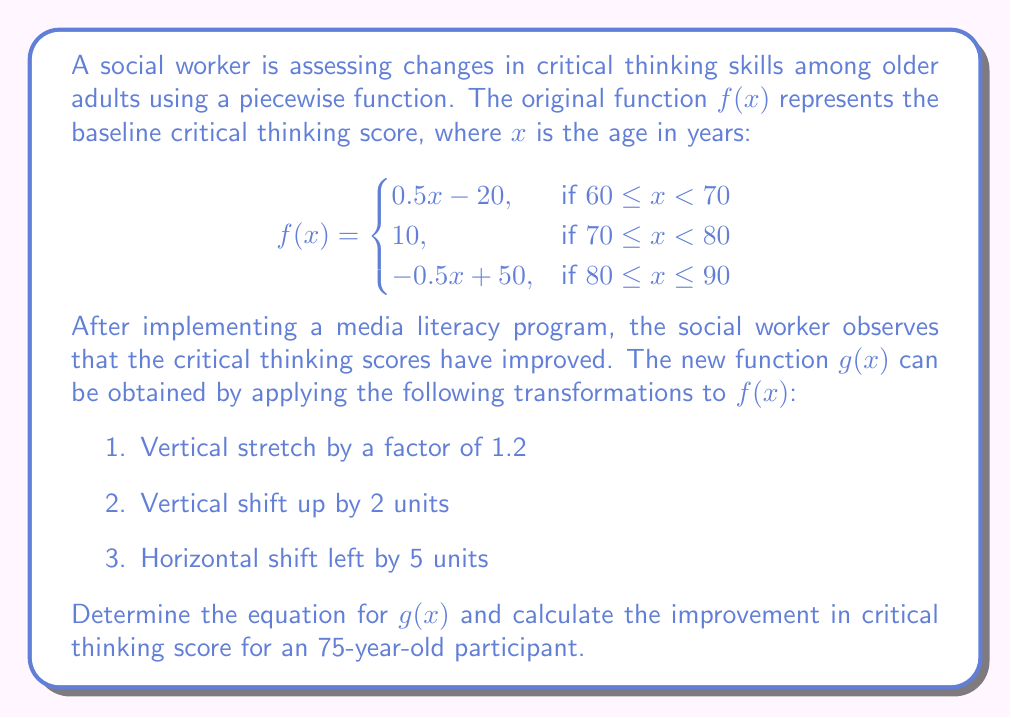Can you solve this math problem? Let's approach this step-by-step:

1) First, we need to apply the transformations to $f(x)$ to obtain $g(x)$:
   - Vertical stretch: $1.2f(x)$
   - Vertical shift: $1.2f(x) + 2$
   - Horizontal shift: $1.2f(x+5) + 2$

2) Now, let's apply these transformations to each piece of the function:

   For $60 \leq x < 70$:
   $1.2(0.5(x+5) - 20) + 2 = 0.6x + 3 - 24 + 2 = 0.6x - 19$

   For $70 \leq x < 80$:
   $1.2(10) + 2 = 14$

   For $80 \leq x \leq 90$:
   $1.2(-0.5(x+5) + 50) + 2 = -0.6x - 3 + 60 + 2 = -0.6x + 59$

3) We need to adjust the domain for each piece due to the horizontal shift:

$$g(x) = \begin{cases}
0.6x - 19, & \text{if } 55 \leq x < 65 \\
14, & \text{if } 65 \leq x < 75 \\
-0.6x + 59, & \text{if } 75 \leq x \leq 85
\end{cases}$$

4) To calculate the improvement for a 75-year-old participant:
   - In $f(x)$, x = 75 falls in the second piece: $f(75) = 10$
   - In $g(x)$, x = 75 falls in the third piece: $g(75) = -0.6(75) + 59 = 14$

5) The improvement is the difference between $g(75)$ and $f(75)$:
   $14 - 10 = 4$
Answer: $g(x) = \begin{cases}
0.6x - 19, & \text{if } 55 \leq x < 65 \\
14, & \text{if } 65 \leq x < 75 \\
-0.6x + 59, & \text{if } 75 \leq x \leq 85
\end{cases}$
Improvement for 75-year-old: 4 points 